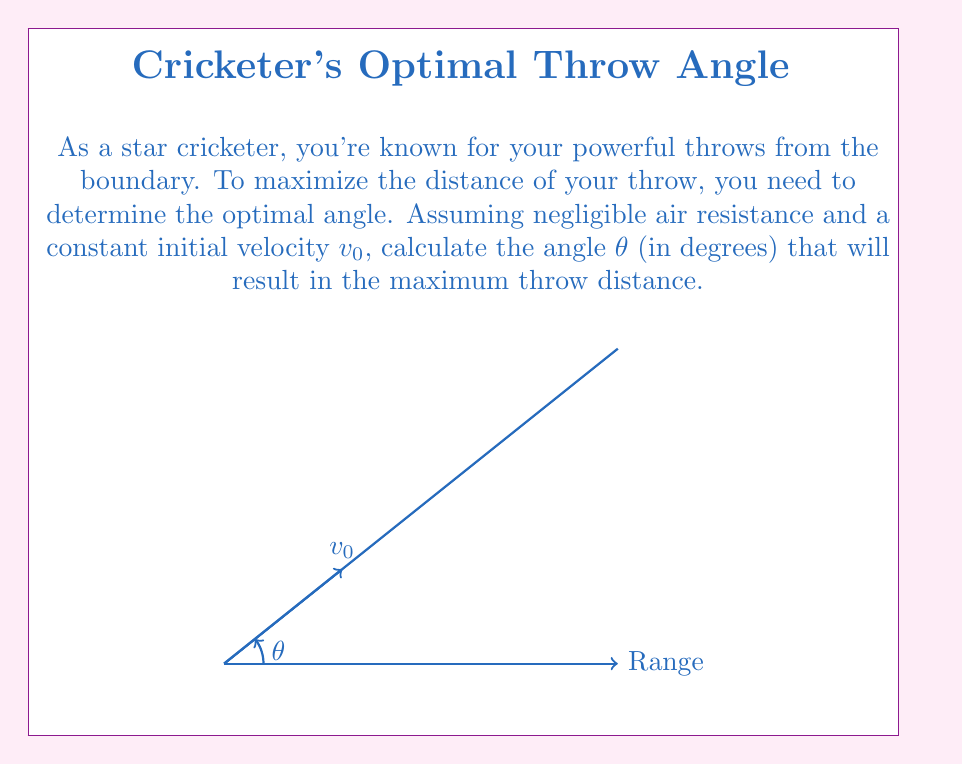Teach me how to tackle this problem. Let's approach this step-by-step:

1) The range (R) of a projectile launched at an angle $\theta$ with initial velocity $v_0$ is given by:

   $$R = \frac{v_0^2 \sin(2\theta)}{g}$$

   where $g$ is the acceleration due to gravity.

2) To find the maximum range, we need to maximize $\sin(2\theta)$.

3) The sine function reaches its maximum value of 1 when its argument is 90°.

4) Therefore, we want:

   $$2\theta = 90°$$

5) Solving for $\theta$:

   $$\theta = 45°$$

6) This result is independent of the initial velocity $v_0$ and the acceleration due to gravity $g$.

7) At this angle, $\sin(2\theta) = \sin(90°) = 1$, ensuring maximum range.

Thus, to achieve the maximum throw distance, you should release the ball at a 45° angle to the horizontal.
Answer: 45° 